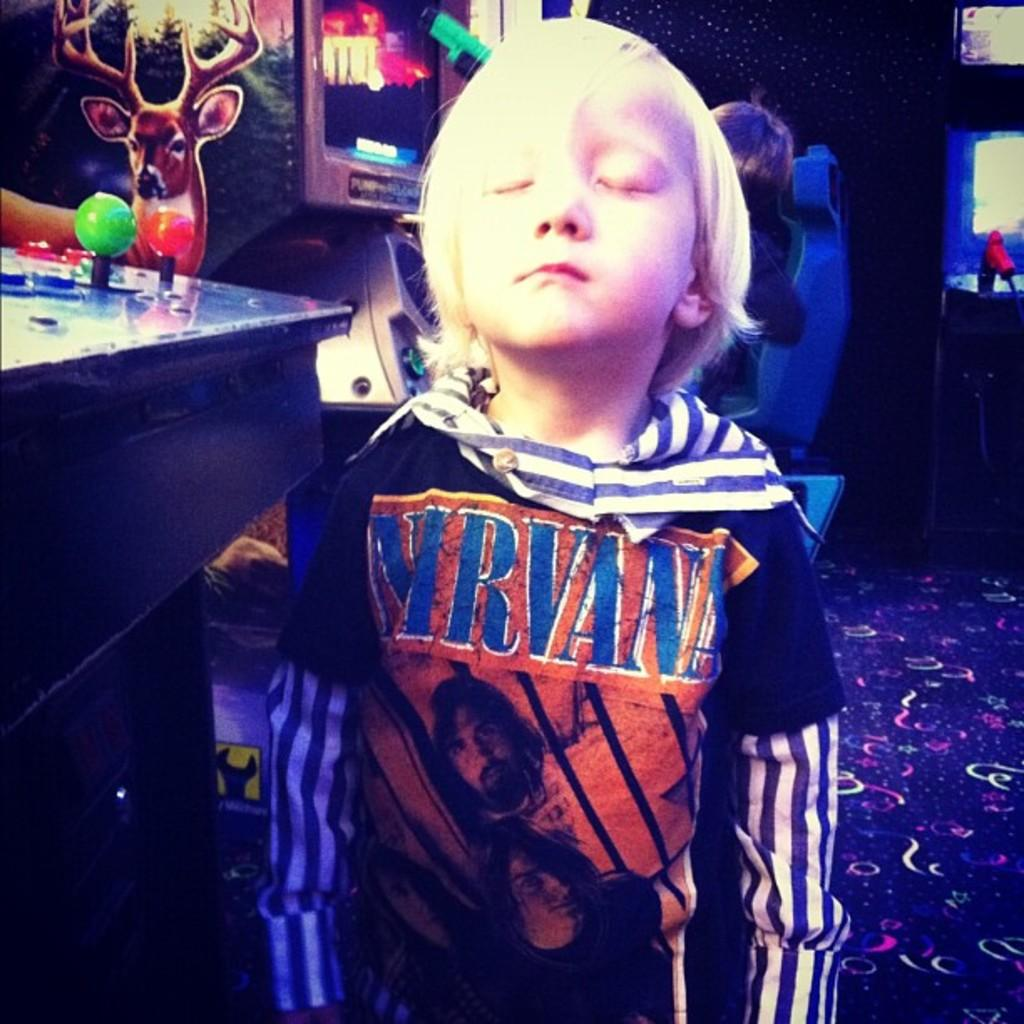<image>
Render a clear and concise summary of the photo. A young boy wearing a Nirvana shirt is closing his eyes. 